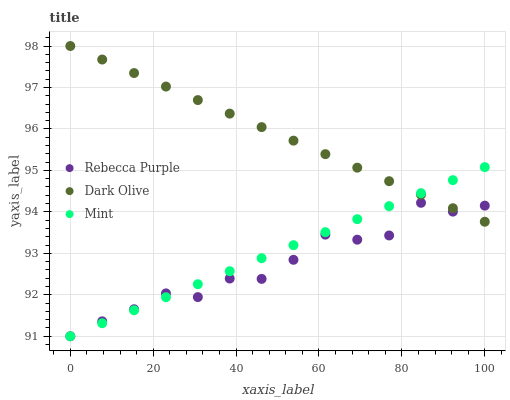Does Rebecca Purple have the minimum area under the curve?
Answer yes or no. Yes. Does Dark Olive have the maximum area under the curve?
Answer yes or no. Yes. Does Mint have the minimum area under the curve?
Answer yes or no. No. Does Mint have the maximum area under the curve?
Answer yes or no. No. Is Mint the smoothest?
Answer yes or no. Yes. Is Rebecca Purple the roughest?
Answer yes or no. Yes. Is Rebecca Purple the smoothest?
Answer yes or no. No. Is Mint the roughest?
Answer yes or no. No. Does Mint have the lowest value?
Answer yes or no. Yes. Does Dark Olive have the highest value?
Answer yes or no. Yes. Does Mint have the highest value?
Answer yes or no. No. Does Mint intersect Rebecca Purple?
Answer yes or no. Yes. Is Mint less than Rebecca Purple?
Answer yes or no. No. Is Mint greater than Rebecca Purple?
Answer yes or no. No. 